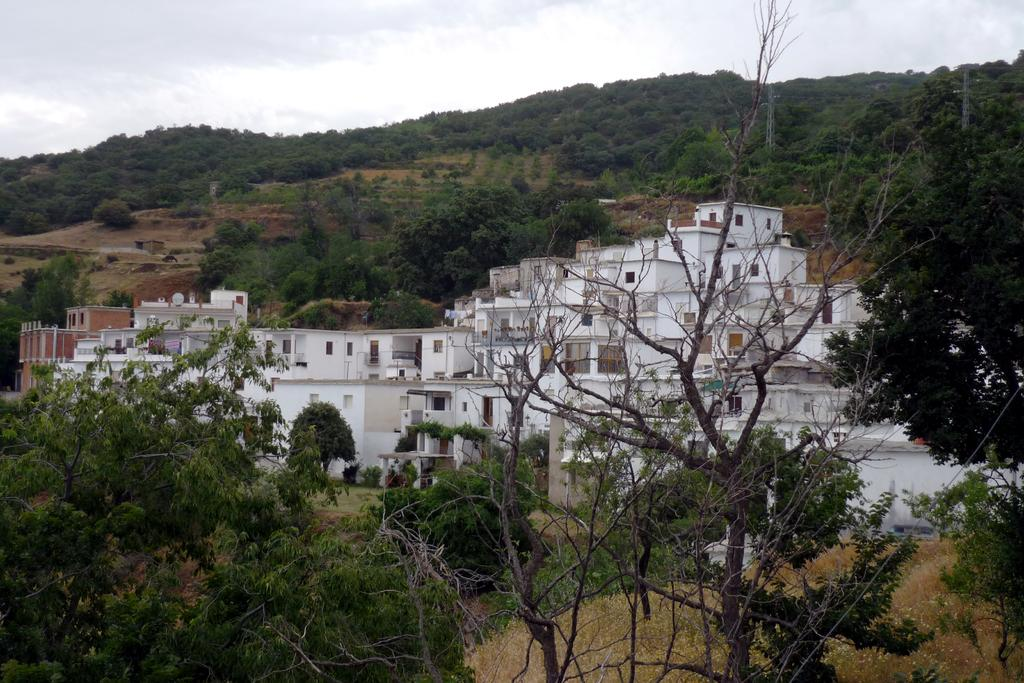What type of natural elements can be seen in the image? There are trees in the image. What type of man-made structures are present in the image? There are buildings in the image. What colors are the buildings? The buildings are white and red in color. What is visible in the background of the image? There is a mountain and the sky visible in the background of the image. Are there any trees on the mountain? Yes, there are trees on the mountain. How many children are visible in the frame of the image? There are no children present in the image. What is the amount of sunlight visible in the image? The provided facts do not mention the amount of sunlight in the image, only the presence of the sky. 